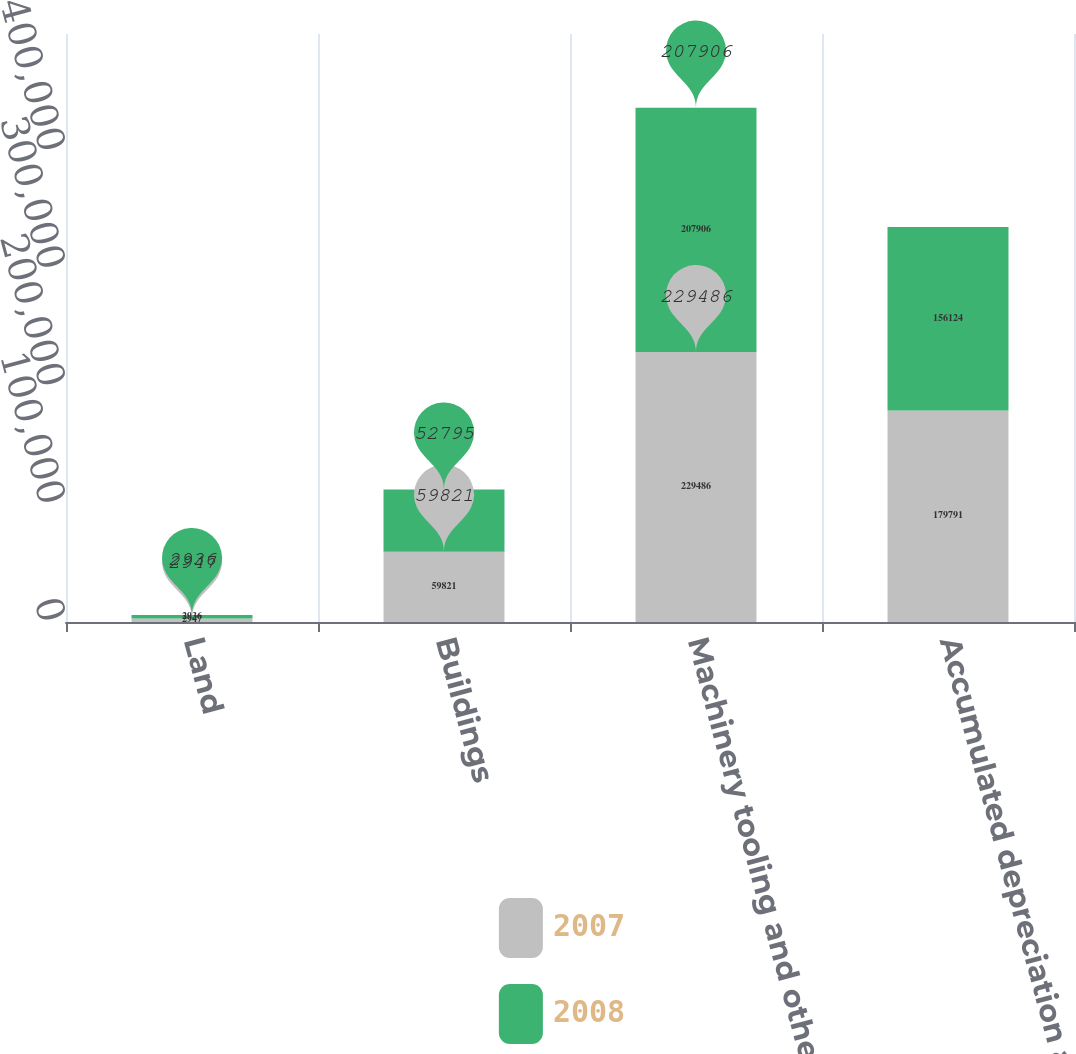Convert chart to OTSL. <chart><loc_0><loc_0><loc_500><loc_500><stacked_bar_chart><ecel><fcel>Land<fcel>Buildings<fcel>Machinery tooling and other<fcel>Accumulated depreciation and<nl><fcel>2007<fcel>2947<fcel>59821<fcel>229486<fcel>179791<nl><fcel>2008<fcel>2936<fcel>52795<fcel>207906<fcel>156124<nl></chart> 